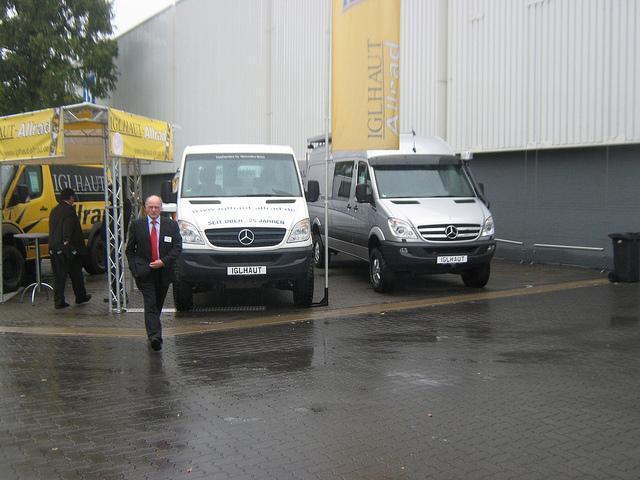How many trucks are there?
Give a very brief answer. 3. How many people can be seen?
Give a very brief answer. 2. How many cars are on the left of the person?
Give a very brief answer. 0. 